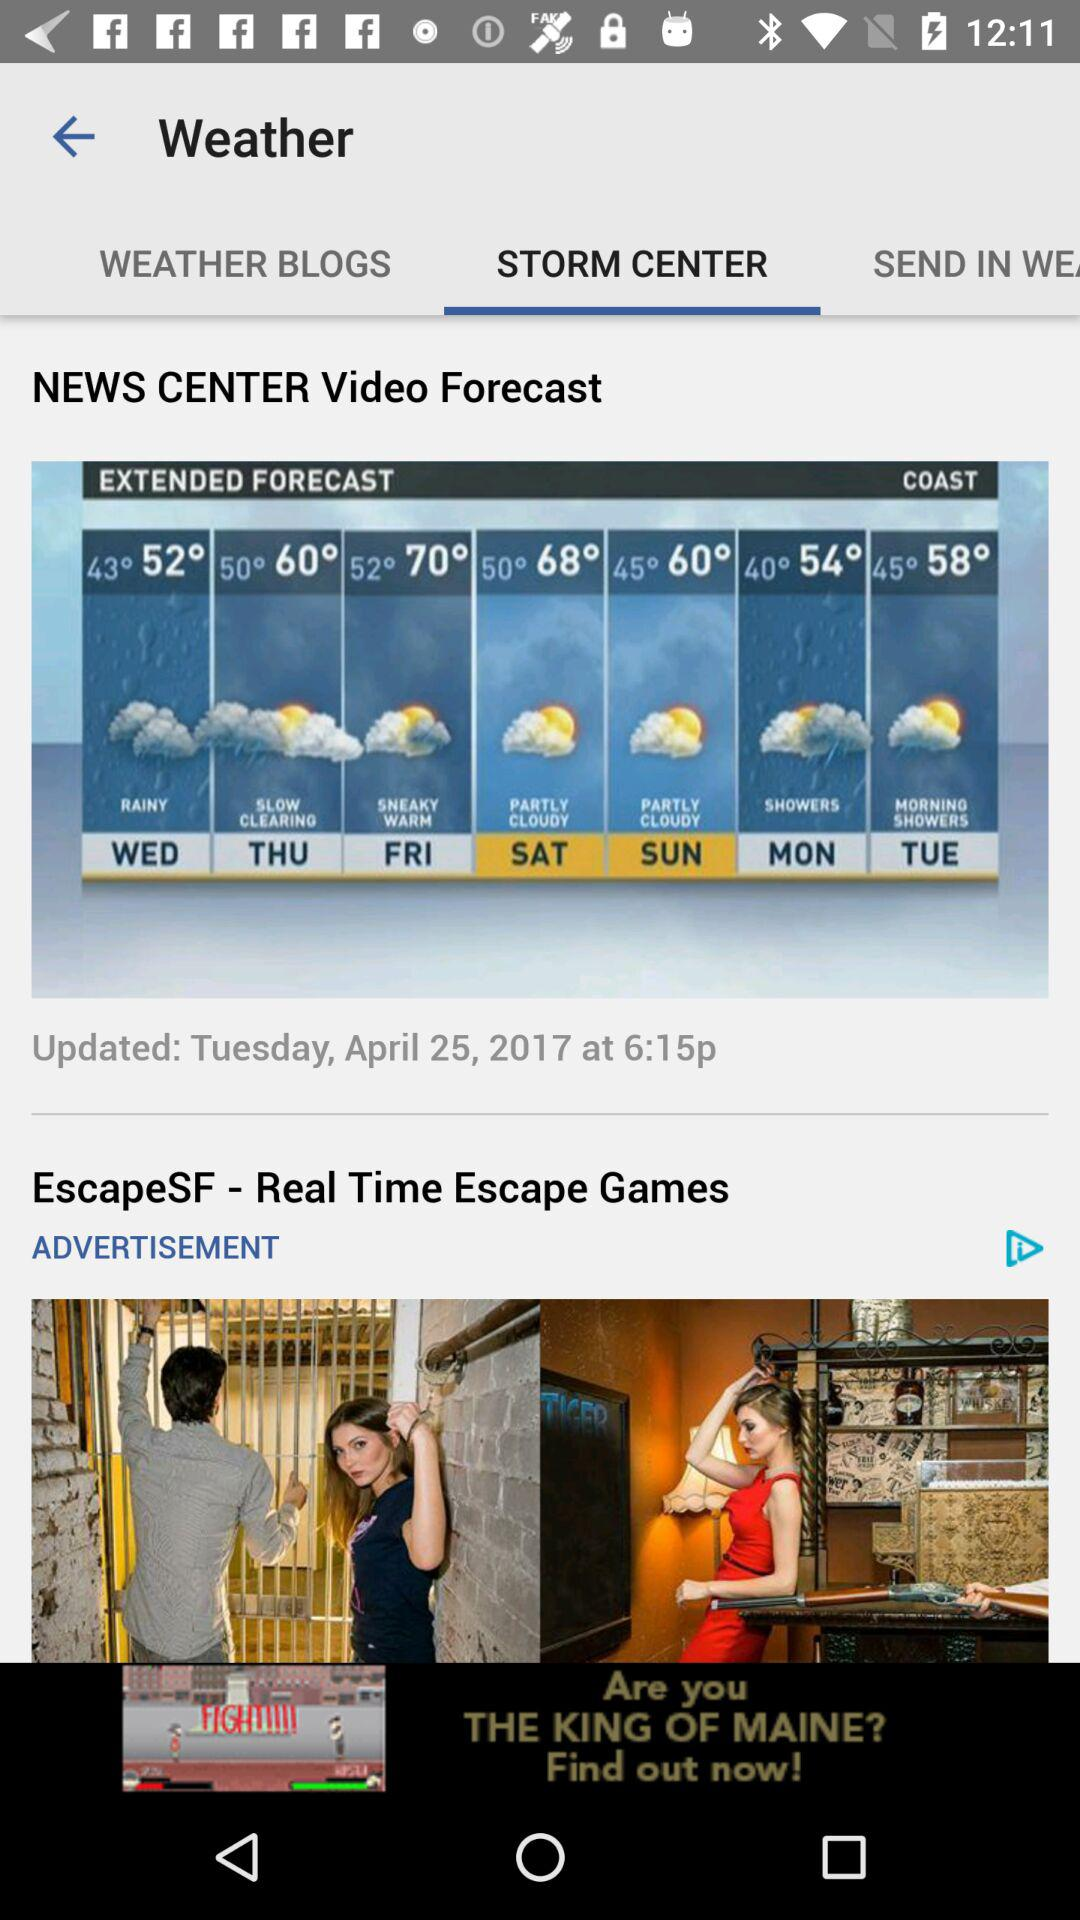What is the temperature on Sunday? The temperature on Sunday ranges from 45° to 60°. 